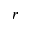Convert formula to latex. <formula><loc_0><loc_0><loc_500><loc_500>r</formula> 